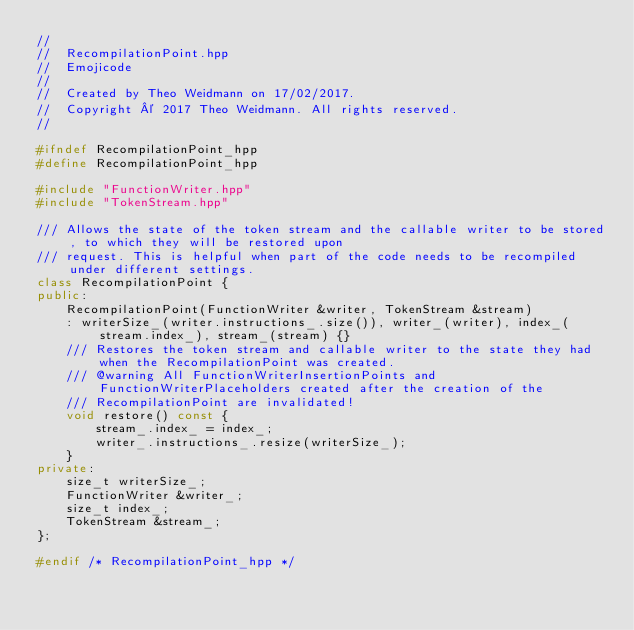Convert code to text. <code><loc_0><loc_0><loc_500><loc_500><_C++_>//
//  RecompilationPoint.hpp
//  Emojicode
//
//  Created by Theo Weidmann on 17/02/2017.
//  Copyright © 2017 Theo Weidmann. All rights reserved.
//

#ifndef RecompilationPoint_hpp
#define RecompilationPoint_hpp

#include "FunctionWriter.hpp"
#include "TokenStream.hpp"

/// Allows the state of the token stream and the callable writer to be stored, to which they will be restored upon
/// request. This is helpful when part of the code needs to be recompiled under different settings.
class RecompilationPoint {
public:
    RecompilationPoint(FunctionWriter &writer, TokenStream &stream)
    : writerSize_(writer.instructions_.size()), writer_(writer), index_(stream.index_), stream_(stream) {}
    /// Restores the token stream and callable writer to the state they had when the RecompilationPoint was created.
    /// @warning All FunctionWriterInsertionPoints and FunctionWriterPlaceholders created after the creation of the
    /// RecompilationPoint are invalidated!
    void restore() const {
        stream_.index_ = index_;
        writer_.instructions_.resize(writerSize_);
    }
private:
    size_t writerSize_;
    FunctionWriter &writer_;
    size_t index_;
    TokenStream &stream_;
};

#endif /* RecompilationPoint_hpp */
</code> 